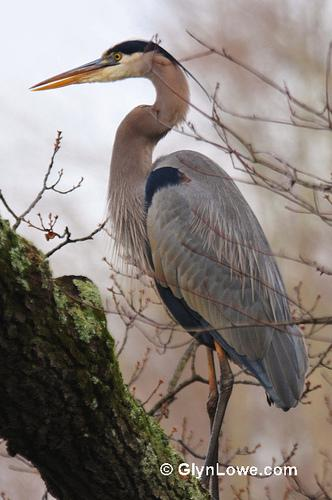Briefly mention the most striking attributes of the subject in the image. A heron with yellow eyes, a pointy beak, blue stomach feathers, and long legs is standing on a mossy tree branch. Describe the bird in the image, its features, and its location. A heron with a grey body, yellow eyes, and a long beak is perched on a mossy tree branch during the winter season. Describe the main character in the image and its distinct features. The bird in the image is a heron characterized by its grey color, long legs, yellow eyes, curved neck, and long beak. Mention the primary focus of the image, its color, and its surroundings. The image focuses on a grey bird with yellow eyes and a pointy beak, perched on a tree branch covered in moss during winter. Provide a short overview of the main subject and its surroundings in the image. The image shows a grey heron with yellow eyes, perched on a mossy tree branch with a backdrop of bare branches. Provide a simple summary of the main components of the image. A heron is perched on a mossy tree branch, featuring yellow eyes, a long beak, and blue stomach area feathers. List the primary aspects of the bird in the image and where it is situated. Grey heron, yellow eyes, long beak, blue stomach feathers, long legs, curved neck, perched on mossy tree branch. In a concise manner, describe the most noticeable features in the image. A grey heron with a long beak, yellow eye, and blue stomach feathers stands on a mossy tree branch with few leaves. Provide a brief description of the primary elements in the image. A grey heron with yellow eyes and a long beak is standing on a moss-covered tree branch with bare limbs in winter season. Summarize the content of the image, highlighting its main details. A grey heron with yellow eyes on a moss-covered tree, featuring long legs, a long beak, and blue stomach area feathers. 